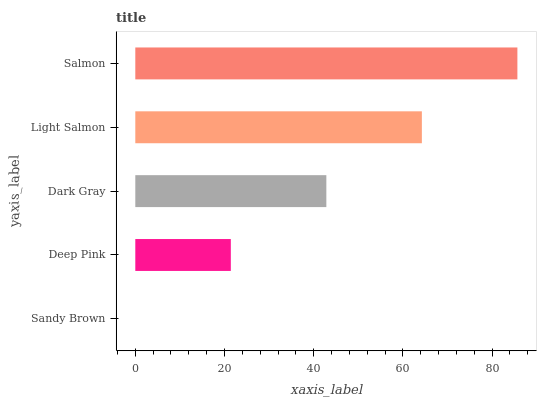Is Sandy Brown the minimum?
Answer yes or no. Yes. Is Salmon the maximum?
Answer yes or no. Yes. Is Deep Pink the minimum?
Answer yes or no. No. Is Deep Pink the maximum?
Answer yes or no. No. Is Deep Pink greater than Sandy Brown?
Answer yes or no. Yes. Is Sandy Brown less than Deep Pink?
Answer yes or no. Yes. Is Sandy Brown greater than Deep Pink?
Answer yes or no. No. Is Deep Pink less than Sandy Brown?
Answer yes or no. No. Is Dark Gray the high median?
Answer yes or no. Yes. Is Dark Gray the low median?
Answer yes or no. Yes. Is Light Salmon the high median?
Answer yes or no. No. Is Light Salmon the low median?
Answer yes or no. No. 